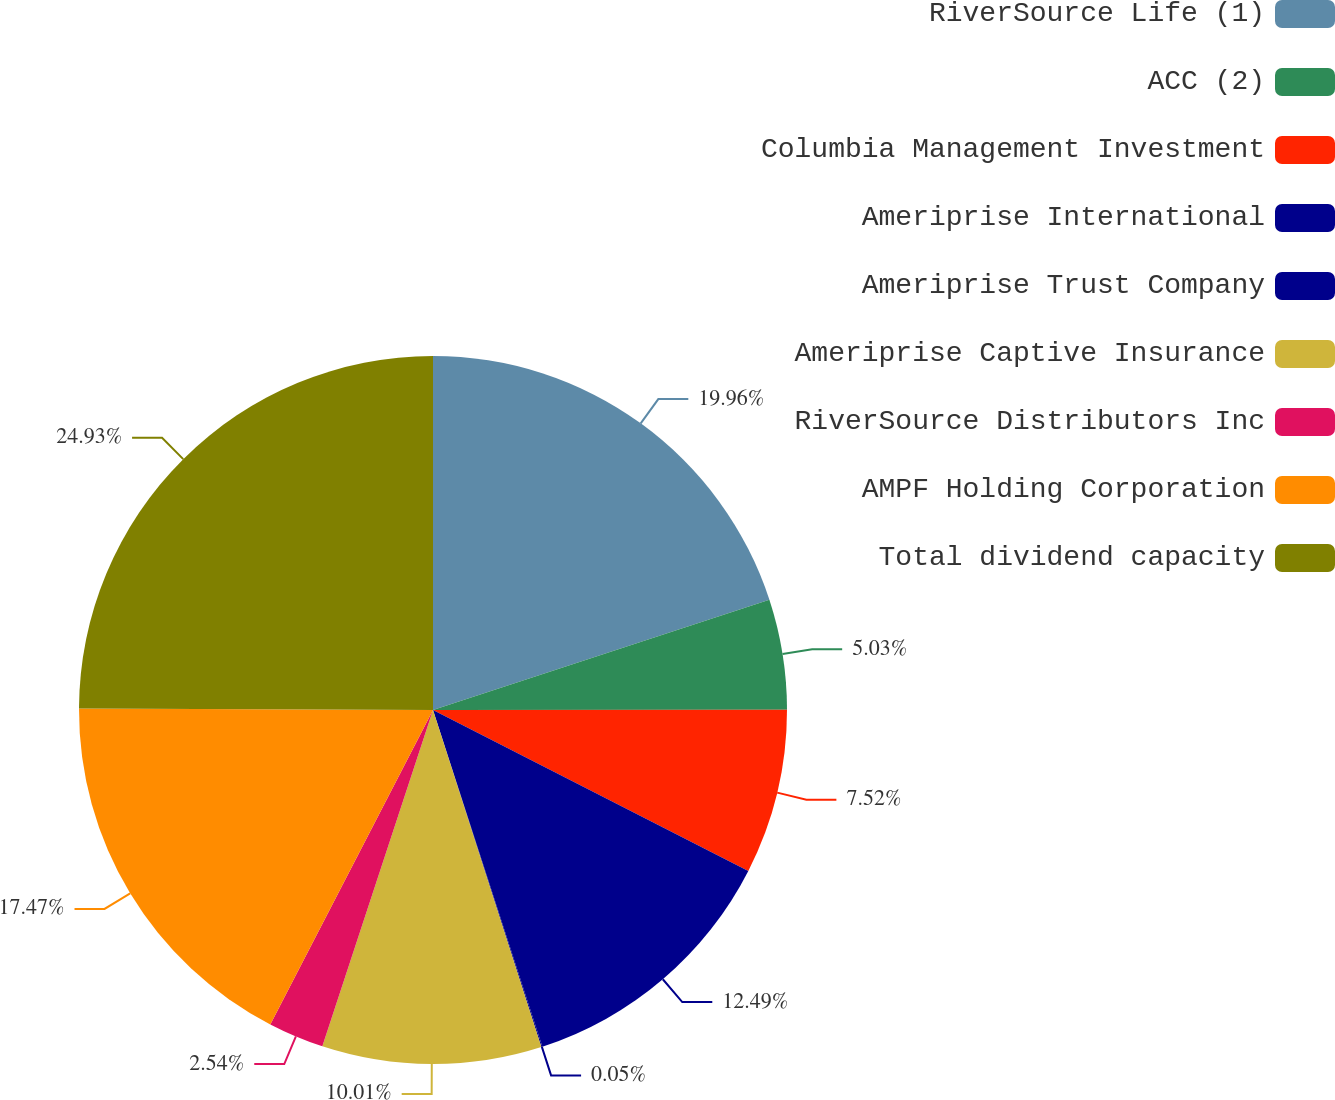Convert chart to OTSL. <chart><loc_0><loc_0><loc_500><loc_500><pie_chart><fcel>RiverSource Life (1)<fcel>ACC (2)<fcel>Columbia Management Investment<fcel>Ameriprise International<fcel>Ameriprise Trust Company<fcel>Ameriprise Captive Insurance<fcel>RiverSource Distributors Inc<fcel>AMPF Holding Corporation<fcel>Total dividend capacity<nl><fcel>19.96%<fcel>5.03%<fcel>7.52%<fcel>12.49%<fcel>0.05%<fcel>10.01%<fcel>2.54%<fcel>17.47%<fcel>24.93%<nl></chart> 